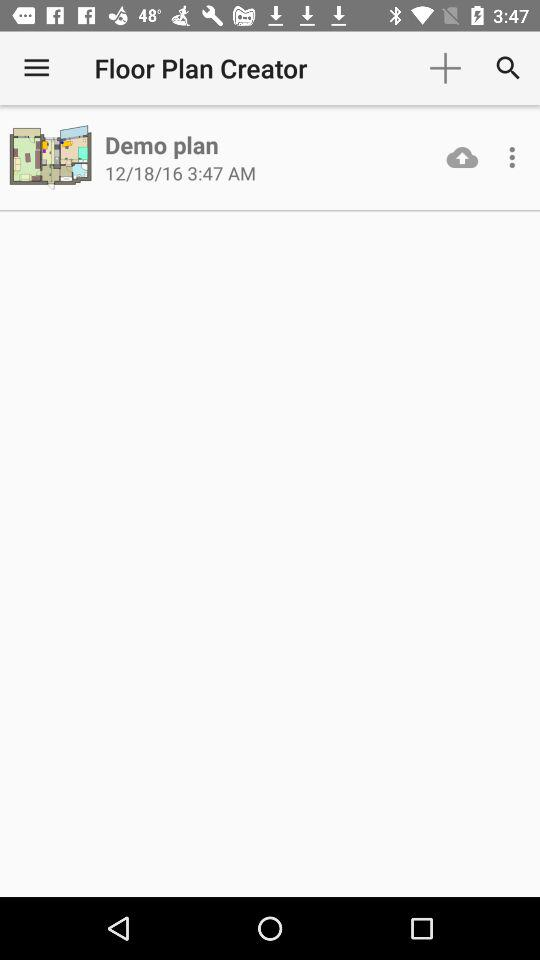What is the name of the folder?
When the provided information is insufficient, respond with <no answer>. <no answer> 